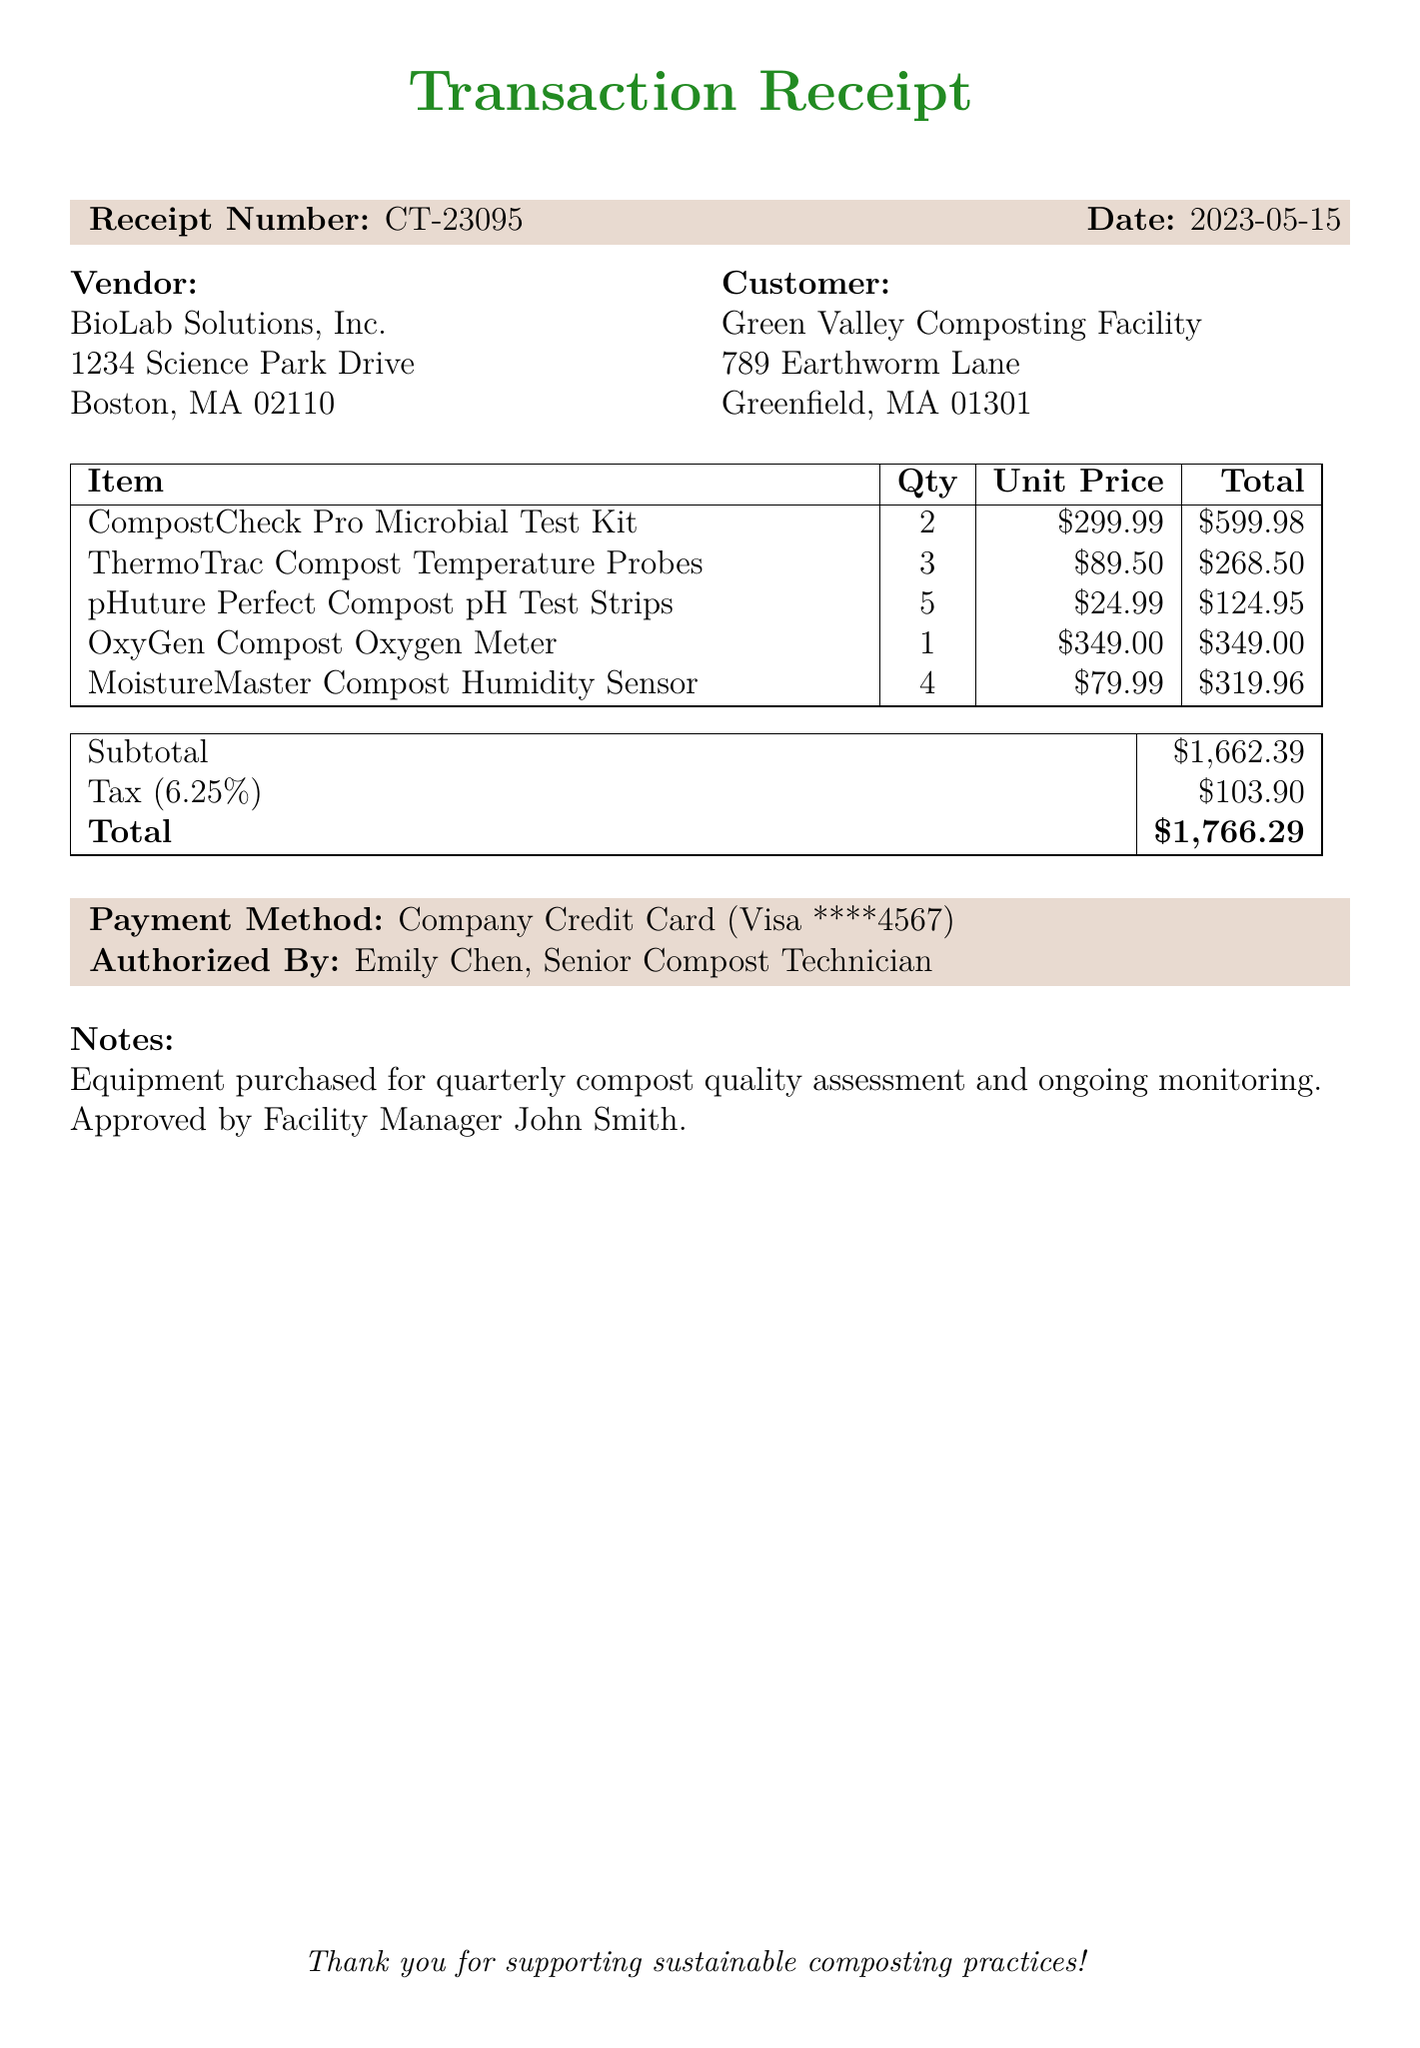what is the receipt number? The receipt number is specified at the top of the document, identifying this specific transaction.
Answer: CT-23095 who is the vendor? The vendor's name is mentioned in the vendor section of the document, indicating who sold the items.
Answer: BioLab Solutions, Inc what is the date of the transaction? The date is prominently displayed on the receipt, indicating when the purchase occurred.
Answer: 2023-05-15 how many "CompostCheck Pro Microbial Test Kits" were purchased? The quantity of this specific item is listed in the items table of the document.
Answer: 2 what is the total amount due? The total amount is clearly stated at the bottom of the receipt, summarizing the entire cost after tax.
Answer: $1,766.29 what items were purchased for compost quality assessment? The notes section mentions the purpose of the items bought, specifically for compost quality assessment.
Answer: quarterly compost quality assessment who authorized the payment? The authorized person is noted at the bottom of the document, indicating who approved the transaction.
Answer: Emily Chen how many "MoistureMaster Compost Humidity Sensors" were included in the purchase? The quantity of this item is specifically noted in the items table, specifying how many were bought.
Answer: 4 what is the tax rate applied to this transaction? The tax rate is mentioned in the summary table, showing how much tax was added to the subtotal.
Answer: 6.25% 